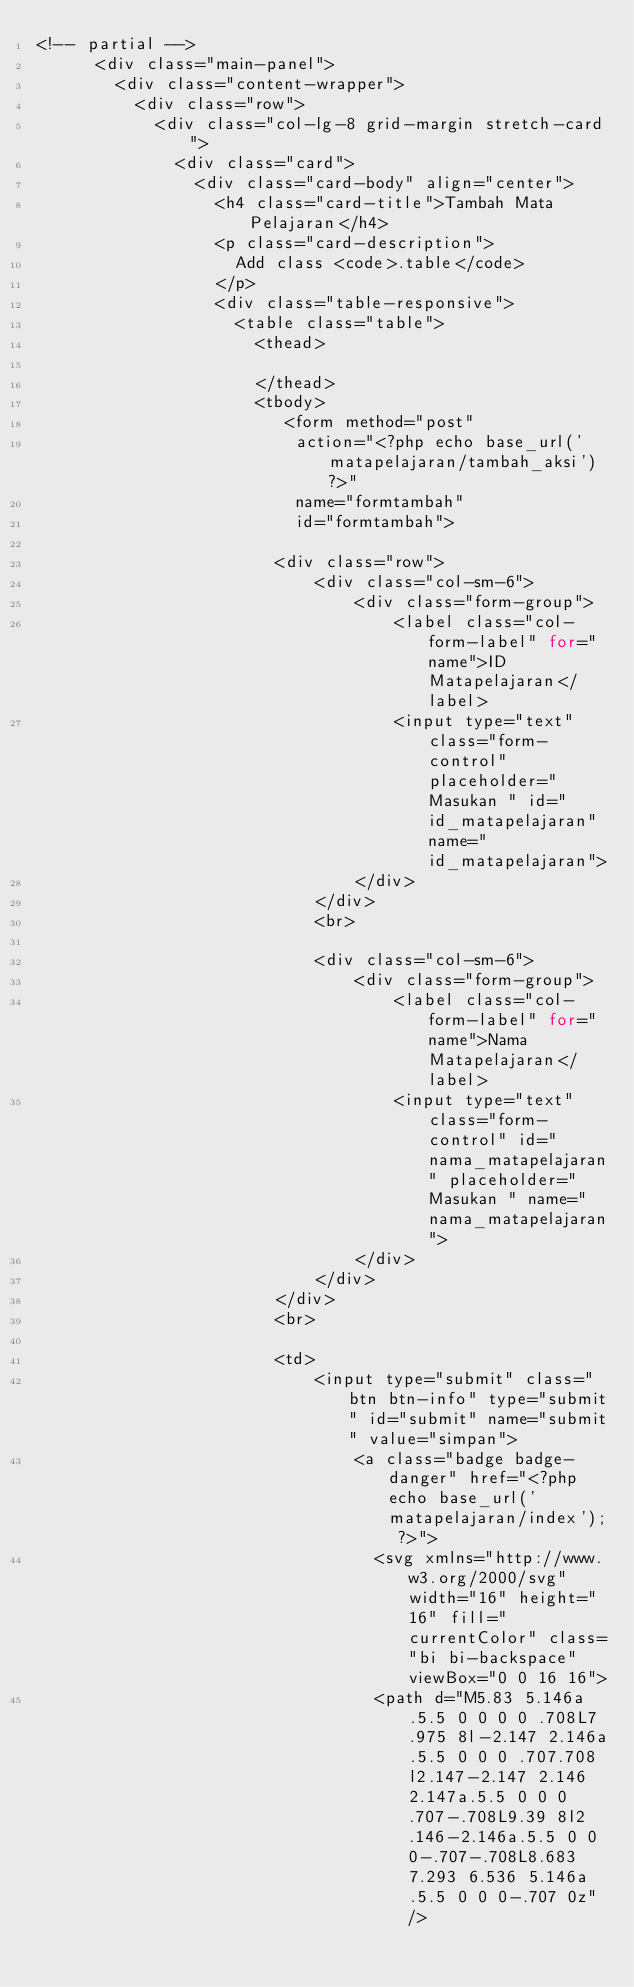<code> <loc_0><loc_0><loc_500><loc_500><_PHP_><!-- partial -->
      <div class="main-panel">
        <div class="content-wrapper">
          <div class="row">
            <div class="col-lg-8 grid-margin stretch-card">
              <div class="card">
                <div class="card-body" align="center">
                  <h4 class="card-title">Tambah Mata Pelajaran</h4>
                  <p class="card-description">
                    Add class <code>.table</code>
                  </p>
                  <div class="table-responsive">
                    <table class="table">
                      <thead>
                        
                      </thead>
                      <tbody>
                         <form method="post"
                          action="<?php echo base_url('matapelajaran/tambah_aksi')?>"
                          name="formtambah"
                          id="formtambah">
                            
                        <div class="row">
                            <div class="col-sm-6">
                                <div class="form-group">
                                    <label class="col-form-label" for="name">ID Matapelajaran</label>
                                    <input type="text" class="form-control" placeholder="Masukan " id="id_matapelajaran" name="id_matapelajaran">
                                </div>
                            </div>
                            <br>

                            <div class="col-sm-6"> 
                                <div class="form-group">
                                    <label class="col-form-label" for="name">Nama Matapelajaran</label>
                                    <input type="text" class="form-control" id="nama_matapelajaran" placeholder="Masukan " name="nama_matapelajaran">
                                </div>
                            </div>
                        </div>
                        <br>

                        <td>
                            <input type="submit" class="btn btn-info" type="submit" id="submit" name="submit" value="simpan">
                                <a class="badge badge-danger" href="<?php echo base_url('matapelajaran/index'); ?>">
                                  <svg xmlns="http://www.w3.org/2000/svg" width="16" height="16" fill="currentColor" class="bi bi-backspace" viewBox="0 0 16 16">
                                  <path d="M5.83 5.146a.5.5 0 0 0 0 .708L7.975 8l-2.147 2.146a.5.5 0 0 0 .707.708l2.147-2.147 2.146 2.147a.5.5 0 0 0 .707-.708L9.39 8l2.146-2.146a.5.5 0 0 0-.707-.708L8.683 7.293 6.536 5.146a.5.5 0 0 0-.707 0z"/></code> 